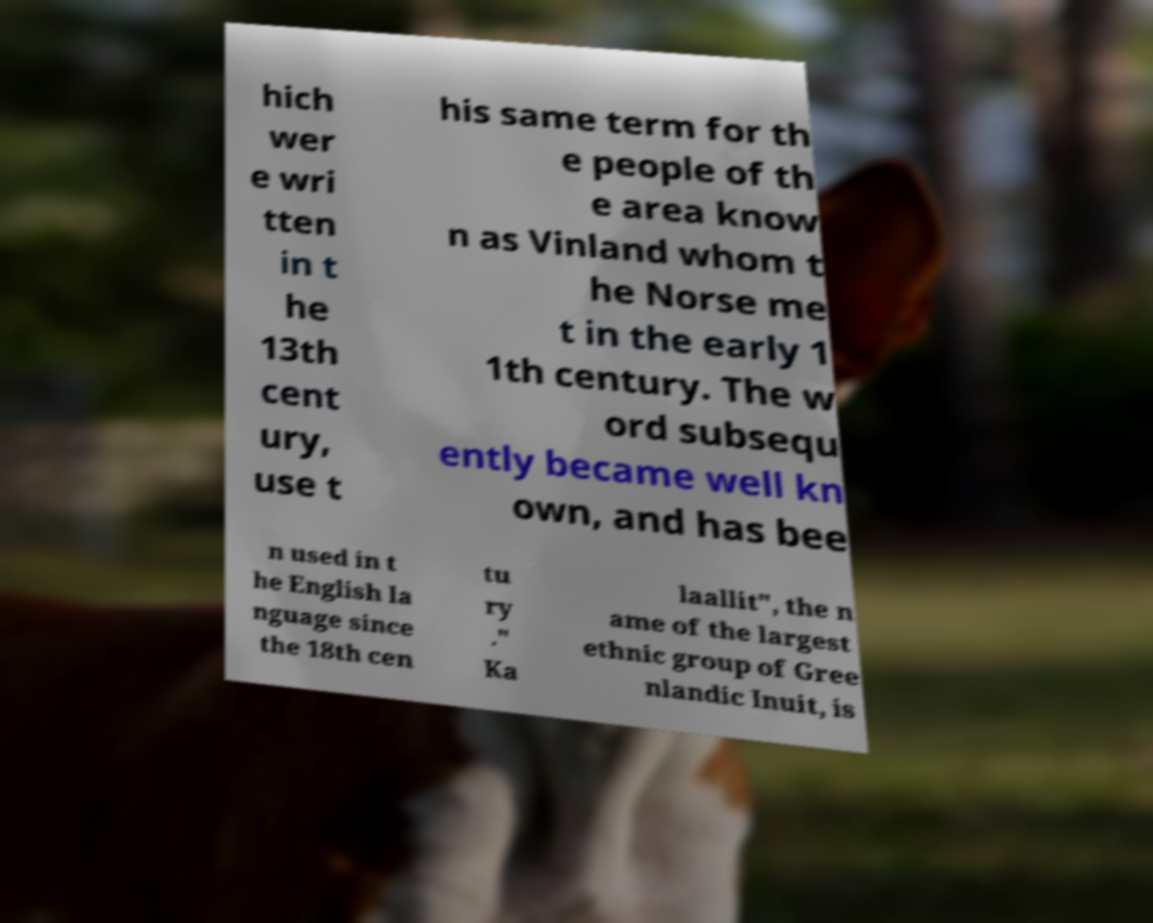Please identify and transcribe the text found in this image. hich wer e wri tten in t he 13th cent ury, use t his same term for th e people of th e area know n as Vinland whom t he Norse me t in the early 1 1th century. The w ord subsequ ently became well kn own, and has bee n used in t he English la nguage since the 18th cen tu ry ." Ka laallit", the n ame of the largest ethnic group of Gree nlandic Inuit, is 